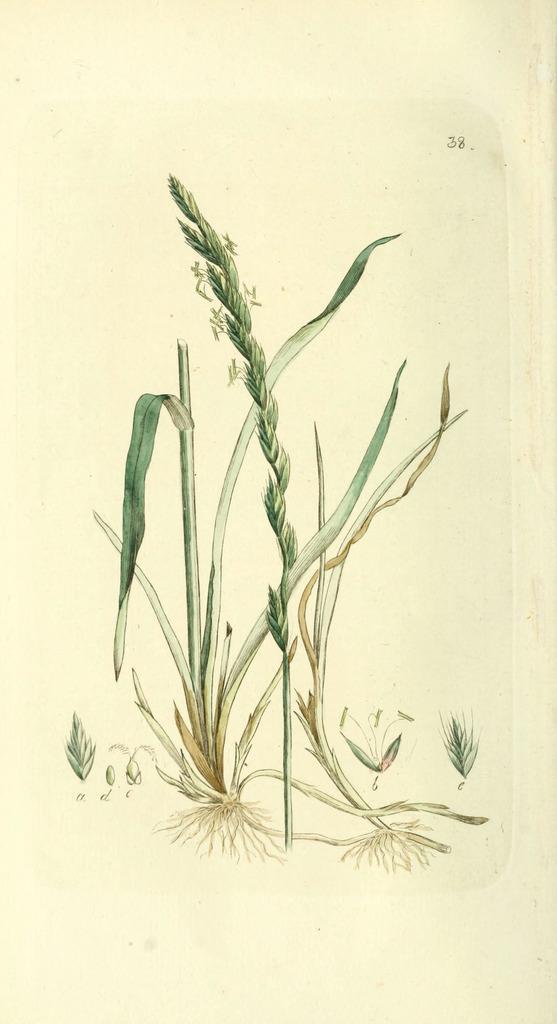Please provide a concise description of this image. In this picture we can see a few plants. There is a number in the top right. 